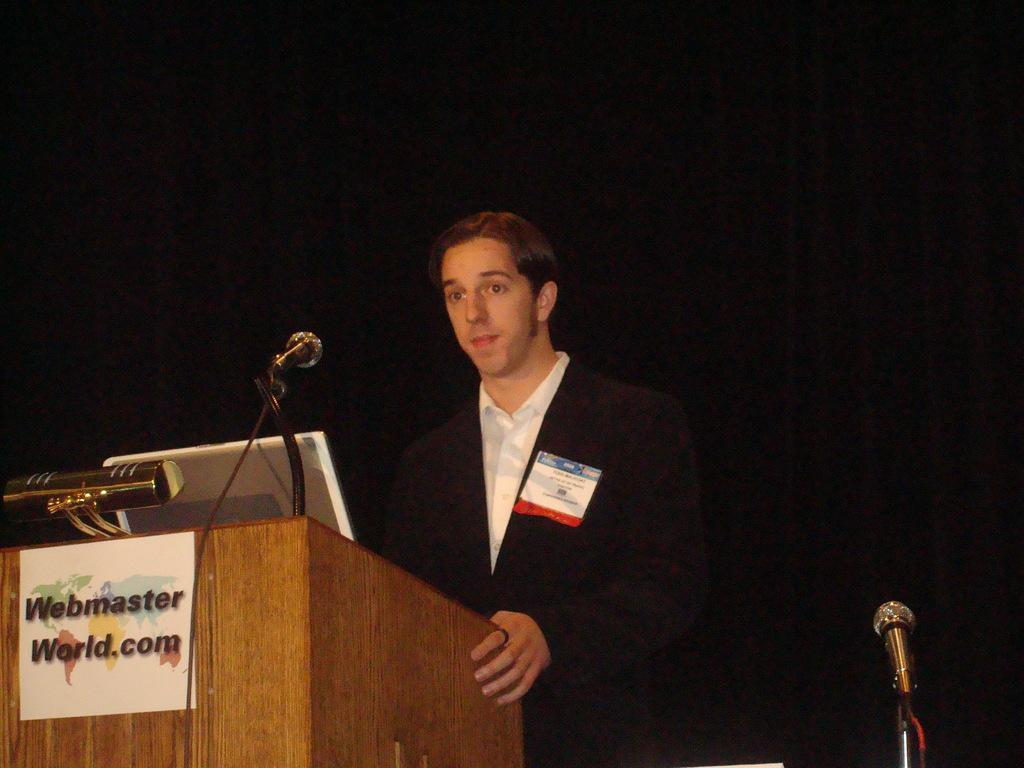How would you summarize this image in a sentence or two? In the picture we can see a person wearing black color dress standing behind wooden podium on which there is laptop, microphone, on right side of the picture there is microphone and in the background there is dark view. 